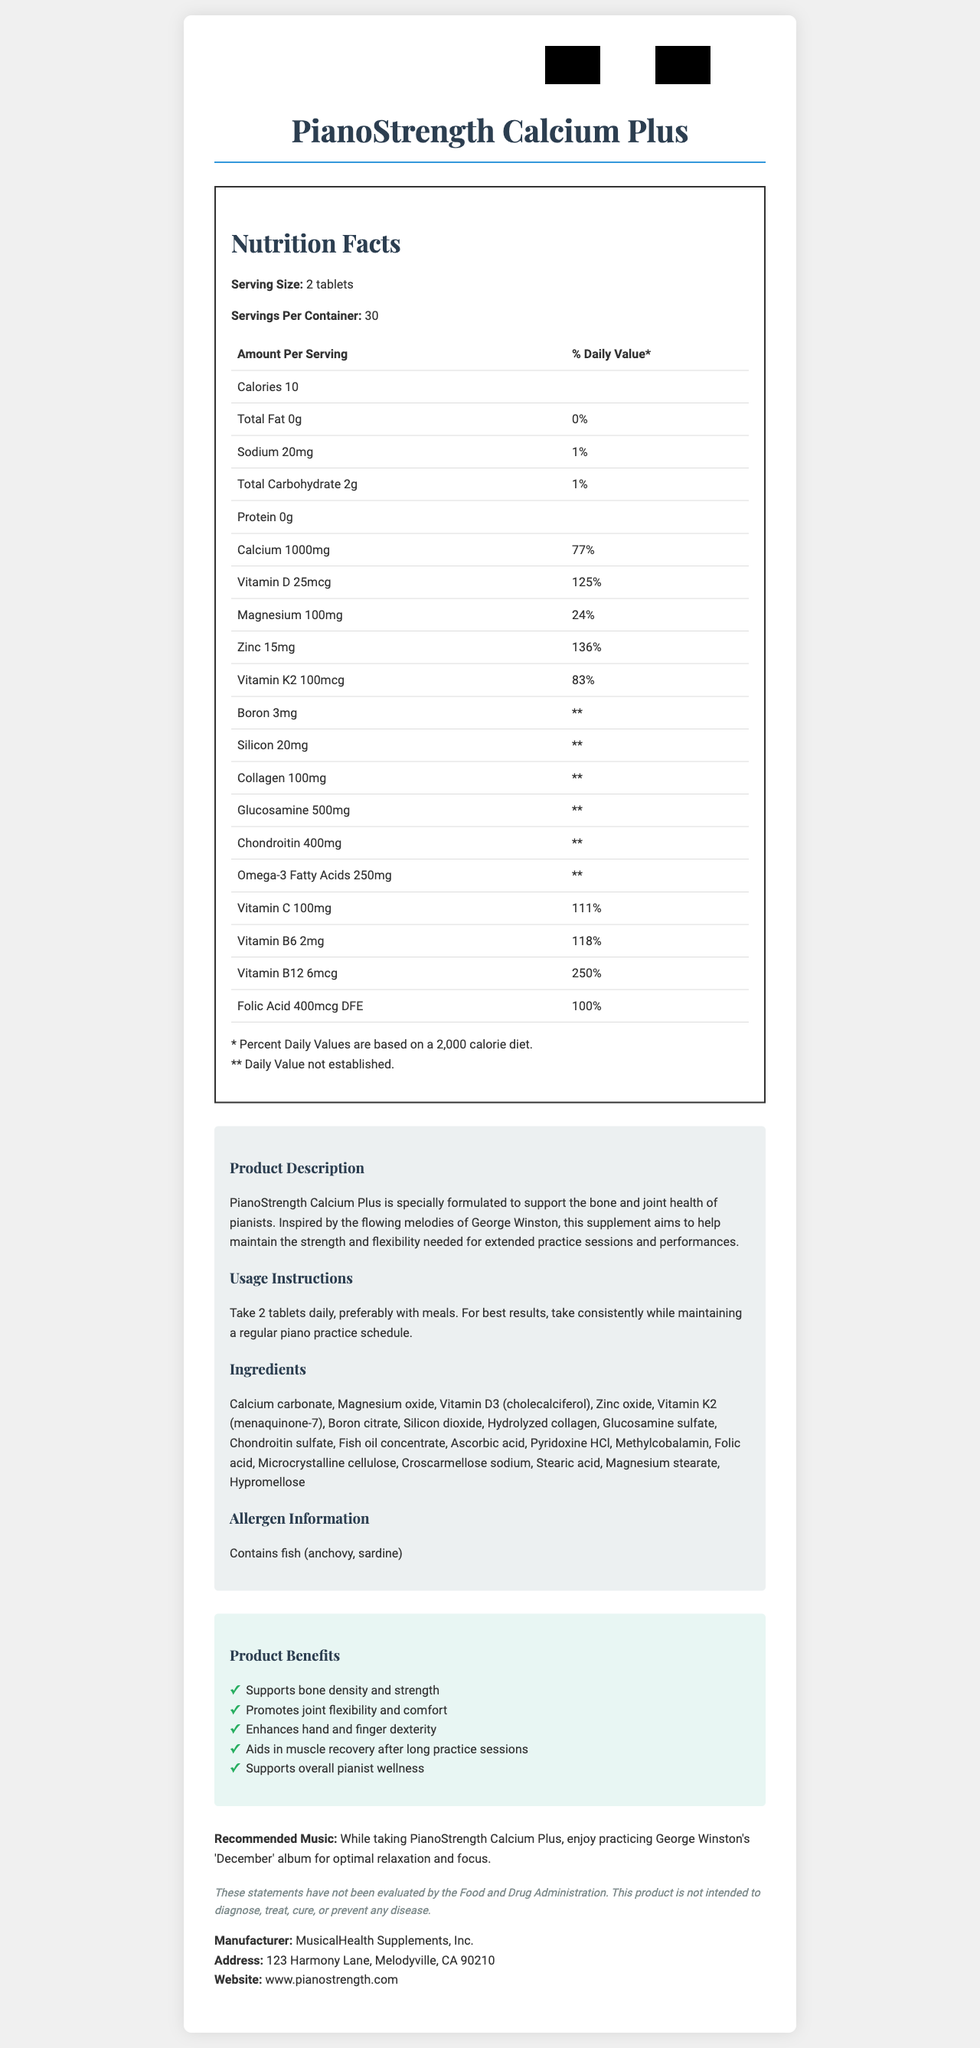who is the manufacturer of PianoStrength Calcium Plus? The document lists MusicalHealth Supplements, Inc. as the manufacturer.
Answer: MusicalHealth Supplements, Inc. what is the serving size of PianoStrength Calcium Plus? The serving size is mentioned as 2 tablets in the Nutrition Facts section.
Answer: 2 tablets name two benefits of taking PianoStrength Calcium Plus. The document has a list of product benefits which include supporting bone density and promoting joint flexibility.
Answer: Supports bone density and strength, Promotes joint flexibility and comfort how many servings are in one container of PianoStrength Calcium Plus? The Nutrition Facts section indicates that there are 30 servings per container.
Answer: 30 what should you avoid if you have a fish allergy? The allergen information specifies that the product contains fish (anchovy, sardine).
Answer: PianoStrength Calcium Plus which vitamin has the highest percentage of the daily value per serving? A. Vitamin B6 B. Vitamin C C. Vitamin D D. Vitamin B12 Vitamin B12 has 250% of the daily value per serving, which is the highest among the listed vitamins.
Answer: D how many calories are there in a serving of PianoStrength Calcium Plus? The document states that each serving contains 10 calories.
Answer: 10 why is this supplement recommended for pianists? This information is provided in the product description and benefits sections.
Answer: It supports bone and joint health, enhances hand and finger dexterity, and aids muscle recovery after practice sessions. which ingredient is responsible for the calcium content in the supplement? A. Calcium carbonate B. Magnesium oxide C. Zinc oxide D. Fish oil concentrate Calcium carbonate is the ingredient that provides calcium.
Answer: A what percentage of the daily value for calcium does a serving of PianoStrength Calcium Plus provide? The Nutrition Facts section lists calcium as providing 77% of the daily value per serving.
Answer: 77% is the product suitable for vegetarians? The supplement contains fish (anchovy, sardine), making it unsuitable for vegetarians.
Answer: No summarize the main purpose of the document. The document aims to inform potential consumers about the benefits, composition, and usage of the supplement.
Answer: The document provides detailed information about PianoStrength Calcium Plus, a calcium-rich supplement designed to support the bone and joint health of pianists. It includes nutrition facts, serving size, usage instructions, ingredients, allergen information, product benefits, and manufacturer details. does this document recommend specific music to listen to while taking the supplement? The document recommends practicing George Winston's 'December' album for optimal relaxation and focus.
Answer: Yes what are the daily values for boron, silicon, collagen, glucosamine, and chondroitin? This information is indicated by the "** Daily Value not established" label in the Nutrition Facts section.
Answer: Daily values are not established for boron, silicon, collagen, glucosamine, and chondroitin. where is the manufacturer located? The address of the manufacturer is listed in the document.
Answer: 123 Harmony Lane, Melodyville, CA 90210 what is the role of hypromellose in the supplement? The document lists hypromellose as an ingredient but does not describe its specific role.
Answer: Not enough information 